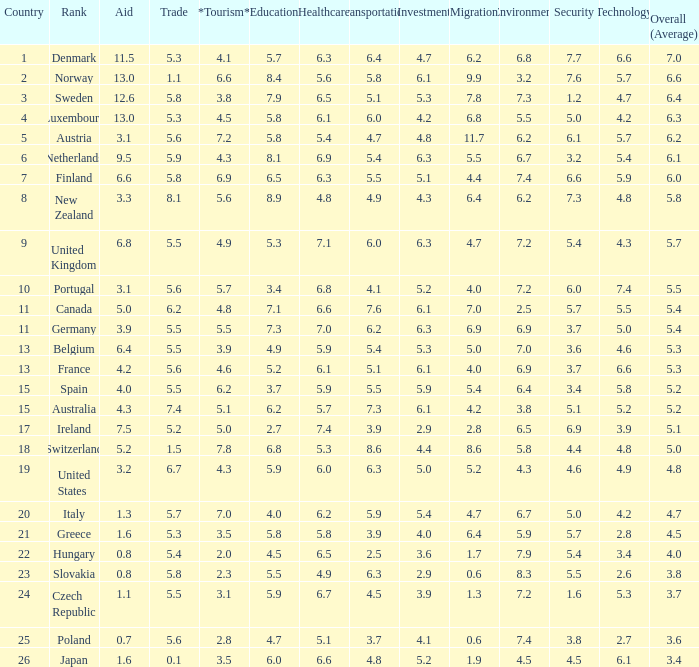What is the environment rating of the country with an overall average rating of 4.7? 6.7. 